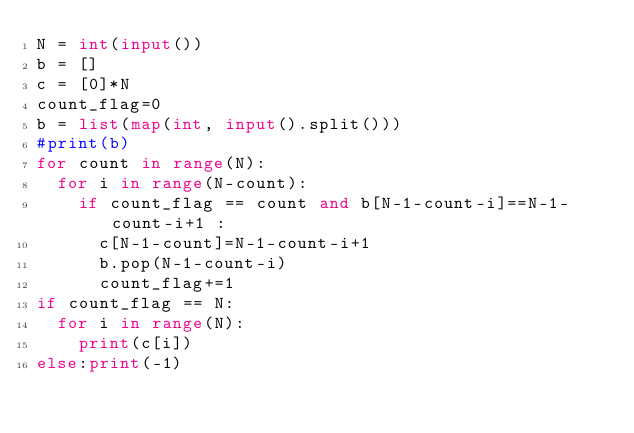<code> <loc_0><loc_0><loc_500><loc_500><_Python_>N = int(input())
b = []
c = [0]*N
count_flag=0
b = list(map(int, input().split()))
#print(b)
for count in range(N):
  for i in range(N-count):
    if count_flag == count and b[N-1-count-i]==N-1-count-i+1 :
      c[N-1-count]=N-1-count-i+1
      b.pop(N-1-count-i)
      count_flag+=1
if count_flag == N:
  for i in range(N):
    print(c[i])
else:print(-1)</code> 